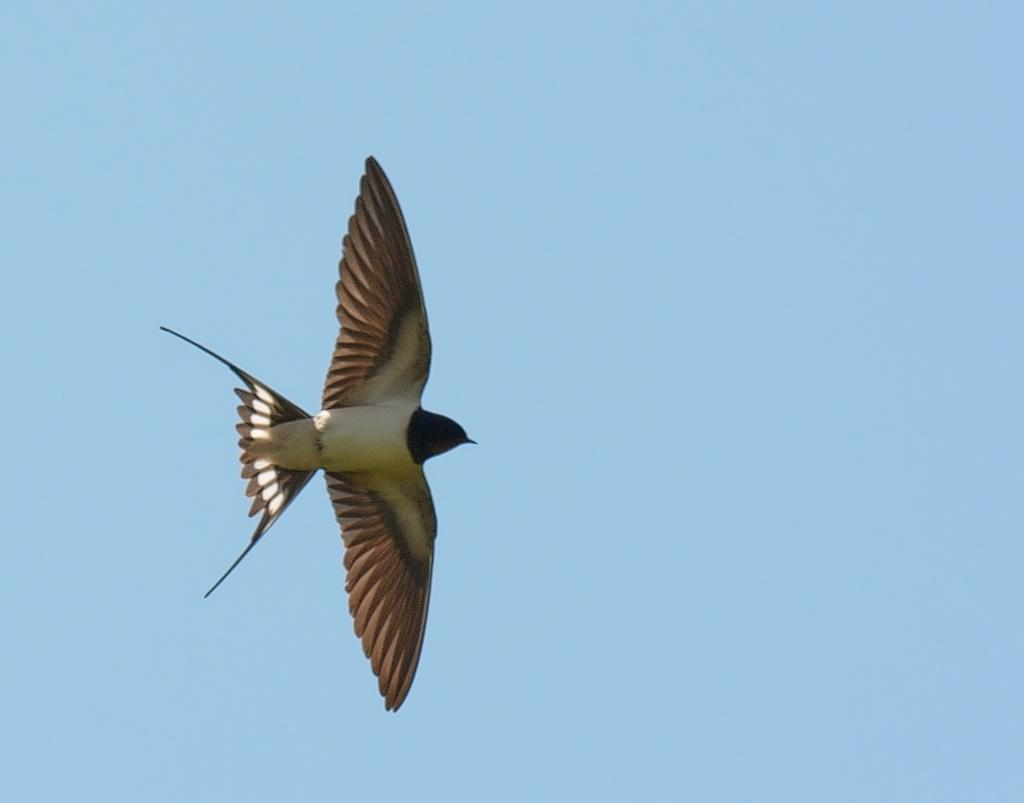What type of animal can be seen in the image? There is a bird in the image. What is the bird doing in the image? The bird is flying in the air. What can be seen in the background of the image? The sky is visible in the background of the image. What type of authority does the bird have in the image? The image does not depict any authority or hierarchy among the bird or other elements. 